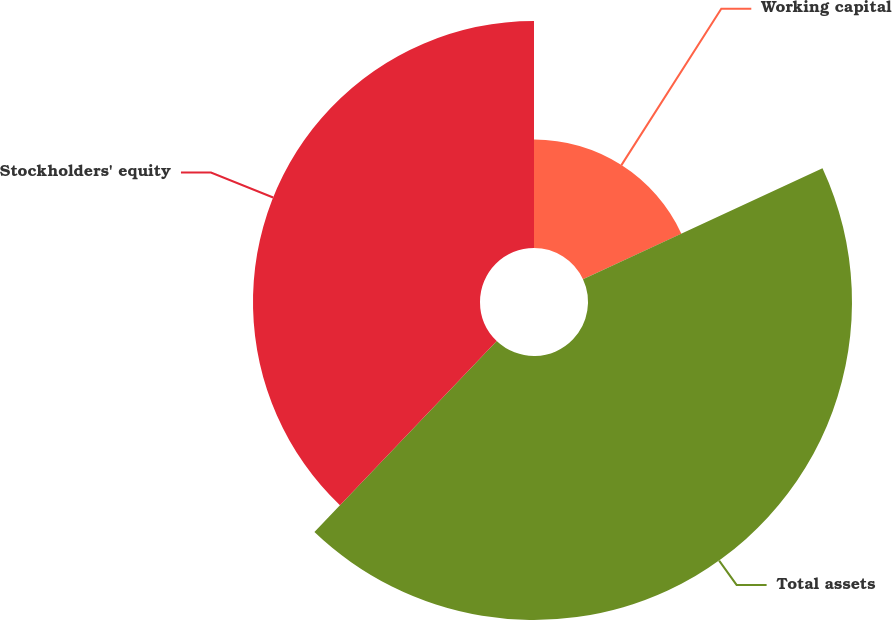Convert chart. <chart><loc_0><loc_0><loc_500><loc_500><pie_chart><fcel>Working capital<fcel>Total assets<fcel>Stockholders' equity<nl><fcel>18.09%<fcel>44.04%<fcel>37.87%<nl></chart> 